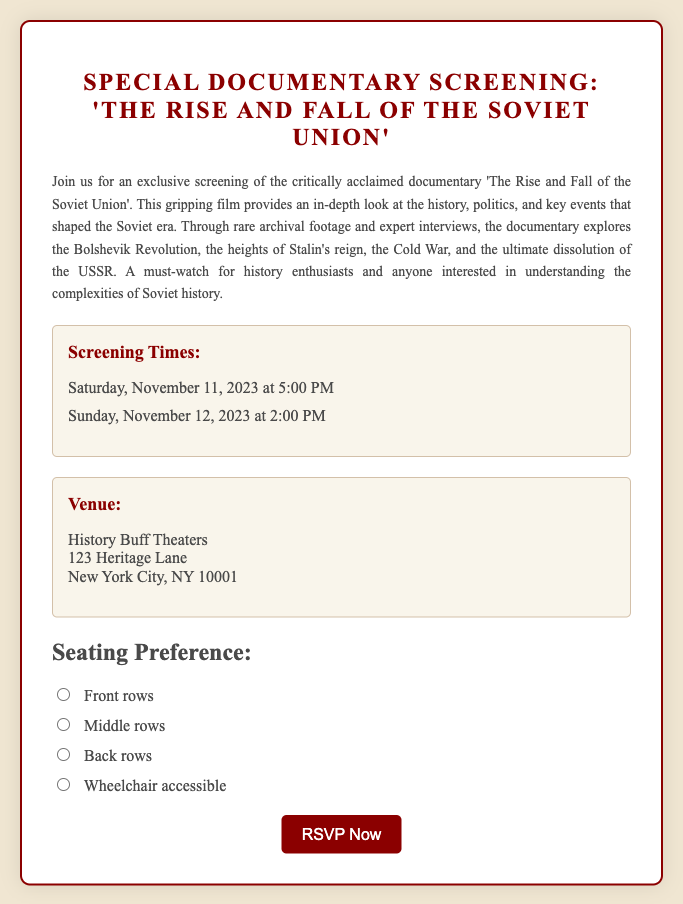What is the title of the documentary? The title of the documentary is provided in the heading of the RSVP card.
Answer: The Rise and Fall of the Soviet Union What are the screening times? The screening times are listed in a specific section on the RSVP card.
Answer: Saturday, November 11, 2023 at 5:00 PM and Sunday, November 12, 2023 at 2:00 PM Where is the venue located? The venue address is detailed in the venue section of the RSVP card.
Answer: History Buff Theaters, 123 Heritage Lane, New York City, NY 10001 What seating preference options are available? The seating preference options are listed under the seating section of the RSVP card.
Answer: Front rows, Middle rows, Back rows, Wheelchair accessible What type of event is this RSVP card for? The type of event is indicated in the title of the RSVP card.
Answer: Special Documentary Screening How many screening times are provided? The number of screening times can be counted from the list provided in the document.
Answer: 2 